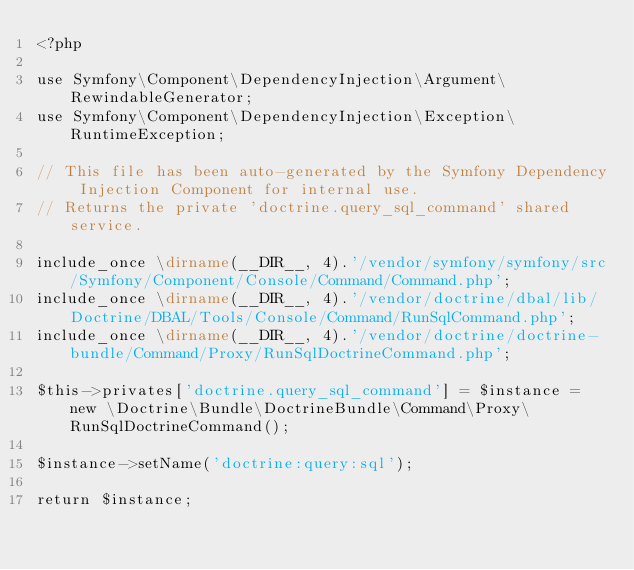Convert code to text. <code><loc_0><loc_0><loc_500><loc_500><_PHP_><?php

use Symfony\Component\DependencyInjection\Argument\RewindableGenerator;
use Symfony\Component\DependencyInjection\Exception\RuntimeException;

// This file has been auto-generated by the Symfony Dependency Injection Component for internal use.
// Returns the private 'doctrine.query_sql_command' shared service.

include_once \dirname(__DIR__, 4).'/vendor/symfony/symfony/src/Symfony/Component/Console/Command/Command.php';
include_once \dirname(__DIR__, 4).'/vendor/doctrine/dbal/lib/Doctrine/DBAL/Tools/Console/Command/RunSqlCommand.php';
include_once \dirname(__DIR__, 4).'/vendor/doctrine/doctrine-bundle/Command/Proxy/RunSqlDoctrineCommand.php';

$this->privates['doctrine.query_sql_command'] = $instance = new \Doctrine\Bundle\DoctrineBundle\Command\Proxy\RunSqlDoctrineCommand();

$instance->setName('doctrine:query:sql');

return $instance;
</code> 